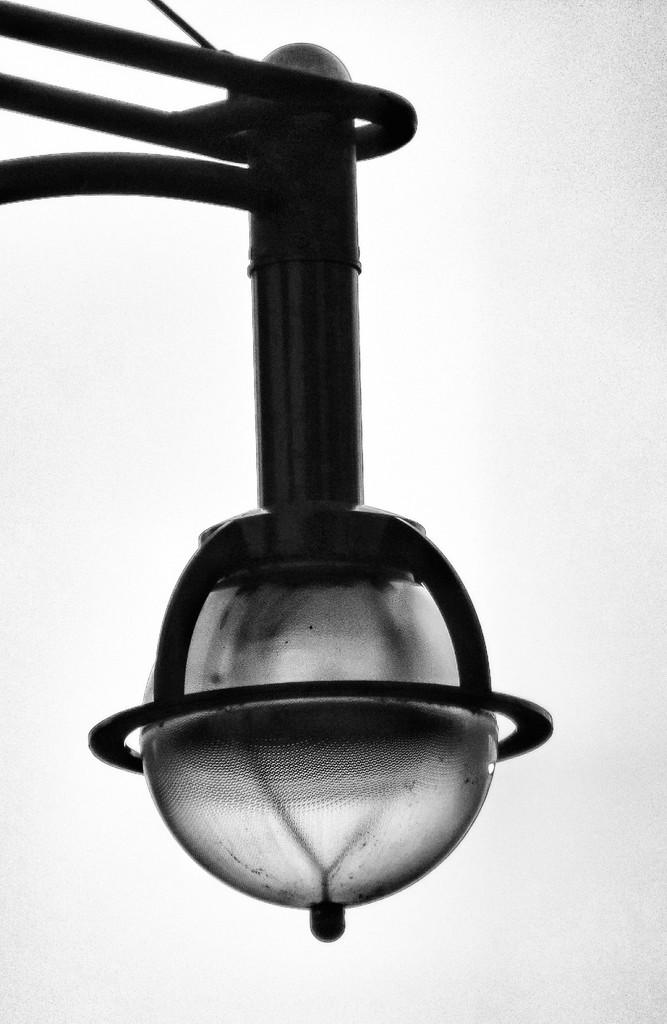What is the color scheme of the image? The image is black and white. What object is present in the image? There is a bulb in the image. Is there anything connected to the bulb? Yes, a metal rod is attached to the bulb. What color is the background of the image? The background is white. Can you see a wave crashing on the shore in the image? No, there is no wave or shore present in the image. Is there a carpenter working on a project in the image? No, there is no carpenter or project visible in the image. 